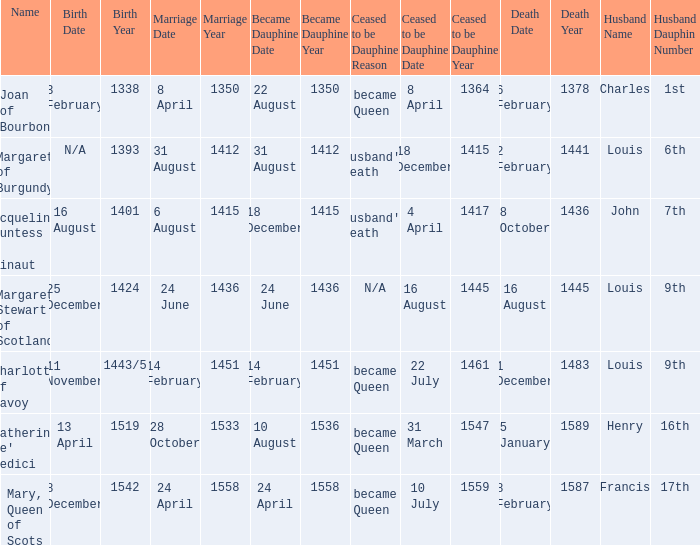When was the death when the birth was 8 december 1542? 8 February 1587. 